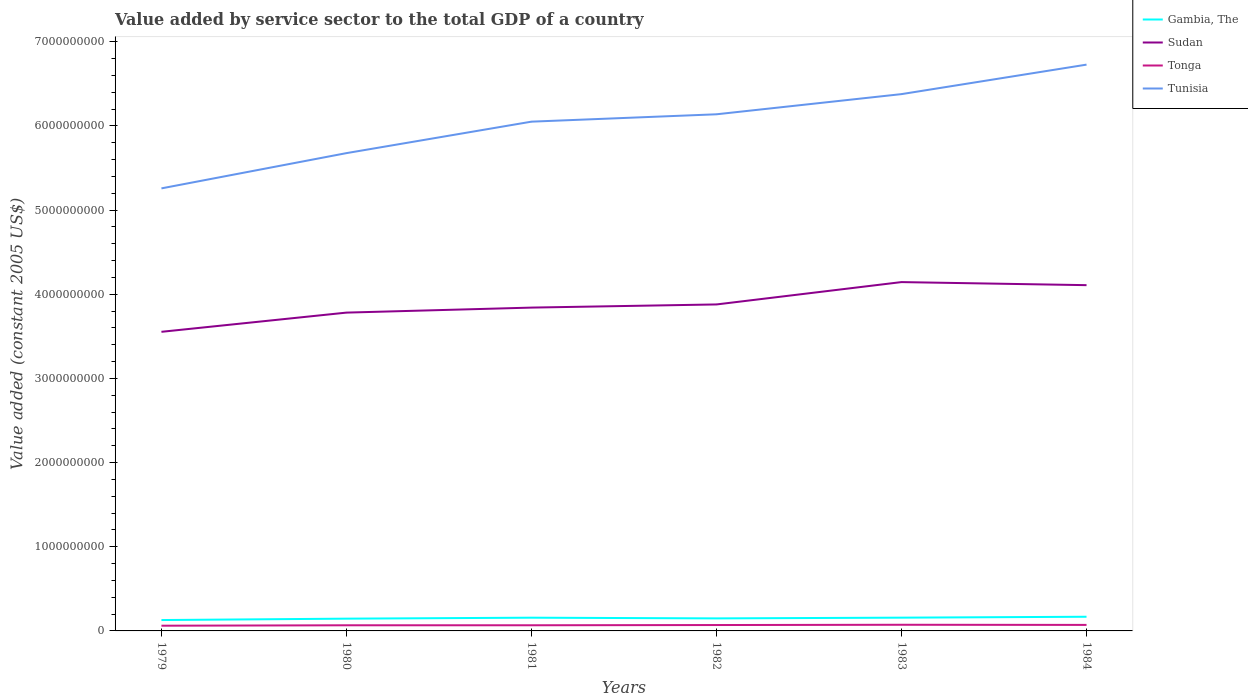Is the number of lines equal to the number of legend labels?
Ensure brevity in your answer.  Yes. Across all years, what is the maximum value added by service sector in Sudan?
Give a very brief answer. 3.55e+09. In which year was the value added by service sector in Tonga maximum?
Ensure brevity in your answer.  1979. What is the total value added by service sector in Tonga in the graph?
Your answer should be very brief. -7.98e+06. What is the difference between the highest and the second highest value added by service sector in Tonga?
Provide a succinct answer. 1.13e+07. What is the difference between the highest and the lowest value added by service sector in Tunisia?
Offer a very short reply. 4. How many lines are there?
Your answer should be compact. 4. How many years are there in the graph?
Your answer should be compact. 6. Does the graph contain any zero values?
Your answer should be compact. No. Does the graph contain grids?
Give a very brief answer. No. Where does the legend appear in the graph?
Provide a succinct answer. Top right. What is the title of the graph?
Your answer should be very brief. Value added by service sector to the total GDP of a country. Does "Micronesia" appear as one of the legend labels in the graph?
Offer a very short reply. No. What is the label or title of the X-axis?
Provide a short and direct response. Years. What is the label or title of the Y-axis?
Give a very brief answer. Value added (constant 2005 US$). What is the Value added (constant 2005 US$) in Gambia, The in 1979?
Your response must be concise. 1.29e+08. What is the Value added (constant 2005 US$) in Sudan in 1979?
Give a very brief answer. 3.55e+09. What is the Value added (constant 2005 US$) of Tonga in 1979?
Offer a terse response. 6.19e+07. What is the Value added (constant 2005 US$) in Tunisia in 1979?
Ensure brevity in your answer.  5.26e+09. What is the Value added (constant 2005 US$) of Gambia, The in 1980?
Provide a short and direct response. 1.46e+08. What is the Value added (constant 2005 US$) of Sudan in 1980?
Your response must be concise. 3.78e+09. What is the Value added (constant 2005 US$) in Tonga in 1980?
Provide a short and direct response. 6.69e+07. What is the Value added (constant 2005 US$) in Tunisia in 1980?
Provide a succinct answer. 5.68e+09. What is the Value added (constant 2005 US$) in Gambia, The in 1981?
Give a very brief answer. 1.57e+08. What is the Value added (constant 2005 US$) in Sudan in 1981?
Make the answer very short. 3.84e+09. What is the Value added (constant 2005 US$) in Tonga in 1981?
Keep it short and to the point. 6.73e+07. What is the Value added (constant 2005 US$) in Tunisia in 1981?
Your response must be concise. 6.05e+09. What is the Value added (constant 2005 US$) in Gambia, The in 1982?
Provide a succinct answer. 1.49e+08. What is the Value added (constant 2005 US$) in Sudan in 1982?
Your answer should be very brief. 3.88e+09. What is the Value added (constant 2005 US$) of Tonga in 1982?
Offer a terse response. 6.99e+07. What is the Value added (constant 2005 US$) of Tunisia in 1982?
Your answer should be compact. 6.14e+09. What is the Value added (constant 2005 US$) in Gambia, The in 1983?
Keep it short and to the point. 1.58e+08. What is the Value added (constant 2005 US$) in Sudan in 1983?
Offer a very short reply. 4.14e+09. What is the Value added (constant 2005 US$) in Tonga in 1983?
Provide a short and direct response. 7.32e+07. What is the Value added (constant 2005 US$) in Tunisia in 1983?
Make the answer very short. 6.38e+09. What is the Value added (constant 2005 US$) of Gambia, The in 1984?
Keep it short and to the point. 1.68e+08. What is the Value added (constant 2005 US$) of Sudan in 1984?
Make the answer very short. 4.11e+09. What is the Value added (constant 2005 US$) in Tonga in 1984?
Your response must be concise. 7.14e+07. What is the Value added (constant 2005 US$) of Tunisia in 1984?
Offer a very short reply. 6.73e+09. Across all years, what is the maximum Value added (constant 2005 US$) in Gambia, The?
Offer a very short reply. 1.68e+08. Across all years, what is the maximum Value added (constant 2005 US$) of Sudan?
Your answer should be very brief. 4.14e+09. Across all years, what is the maximum Value added (constant 2005 US$) in Tonga?
Ensure brevity in your answer.  7.32e+07. Across all years, what is the maximum Value added (constant 2005 US$) in Tunisia?
Your answer should be compact. 6.73e+09. Across all years, what is the minimum Value added (constant 2005 US$) of Gambia, The?
Your answer should be compact. 1.29e+08. Across all years, what is the minimum Value added (constant 2005 US$) of Sudan?
Your answer should be very brief. 3.55e+09. Across all years, what is the minimum Value added (constant 2005 US$) in Tonga?
Your response must be concise. 6.19e+07. Across all years, what is the minimum Value added (constant 2005 US$) of Tunisia?
Your response must be concise. 5.26e+09. What is the total Value added (constant 2005 US$) of Gambia, The in the graph?
Make the answer very short. 9.07e+08. What is the total Value added (constant 2005 US$) in Sudan in the graph?
Give a very brief answer. 2.33e+1. What is the total Value added (constant 2005 US$) of Tonga in the graph?
Give a very brief answer. 4.11e+08. What is the total Value added (constant 2005 US$) of Tunisia in the graph?
Your response must be concise. 3.62e+1. What is the difference between the Value added (constant 2005 US$) of Gambia, The in 1979 and that in 1980?
Offer a terse response. -1.66e+07. What is the difference between the Value added (constant 2005 US$) in Sudan in 1979 and that in 1980?
Provide a succinct answer. -2.28e+08. What is the difference between the Value added (constant 2005 US$) of Tonga in 1979 and that in 1980?
Your answer should be very brief. -4.99e+06. What is the difference between the Value added (constant 2005 US$) in Tunisia in 1979 and that in 1980?
Offer a terse response. -4.19e+08. What is the difference between the Value added (constant 2005 US$) in Gambia, The in 1979 and that in 1981?
Offer a terse response. -2.81e+07. What is the difference between the Value added (constant 2005 US$) of Sudan in 1979 and that in 1981?
Your response must be concise. -2.88e+08. What is the difference between the Value added (constant 2005 US$) in Tonga in 1979 and that in 1981?
Offer a terse response. -5.32e+06. What is the difference between the Value added (constant 2005 US$) in Tunisia in 1979 and that in 1981?
Ensure brevity in your answer.  -7.93e+08. What is the difference between the Value added (constant 2005 US$) of Gambia, The in 1979 and that in 1982?
Offer a very short reply. -1.98e+07. What is the difference between the Value added (constant 2005 US$) of Sudan in 1979 and that in 1982?
Provide a succinct answer. -3.25e+08. What is the difference between the Value added (constant 2005 US$) in Tonga in 1979 and that in 1982?
Your answer should be compact. -7.98e+06. What is the difference between the Value added (constant 2005 US$) in Tunisia in 1979 and that in 1982?
Provide a succinct answer. -8.80e+08. What is the difference between the Value added (constant 2005 US$) of Gambia, The in 1979 and that in 1983?
Provide a short and direct response. -2.84e+07. What is the difference between the Value added (constant 2005 US$) in Sudan in 1979 and that in 1983?
Make the answer very short. -5.91e+08. What is the difference between the Value added (constant 2005 US$) of Tonga in 1979 and that in 1983?
Your answer should be compact. -1.13e+07. What is the difference between the Value added (constant 2005 US$) in Tunisia in 1979 and that in 1983?
Your answer should be very brief. -1.12e+09. What is the difference between the Value added (constant 2005 US$) in Gambia, The in 1979 and that in 1984?
Make the answer very short. -3.92e+07. What is the difference between the Value added (constant 2005 US$) in Sudan in 1979 and that in 1984?
Your response must be concise. -5.54e+08. What is the difference between the Value added (constant 2005 US$) in Tonga in 1979 and that in 1984?
Provide a short and direct response. -9.49e+06. What is the difference between the Value added (constant 2005 US$) of Tunisia in 1979 and that in 1984?
Make the answer very short. -1.47e+09. What is the difference between the Value added (constant 2005 US$) of Gambia, The in 1980 and that in 1981?
Give a very brief answer. -1.15e+07. What is the difference between the Value added (constant 2005 US$) in Sudan in 1980 and that in 1981?
Provide a succinct answer. -5.95e+07. What is the difference between the Value added (constant 2005 US$) of Tonga in 1980 and that in 1981?
Offer a very short reply. -3.28e+05. What is the difference between the Value added (constant 2005 US$) of Tunisia in 1980 and that in 1981?
Offer a terse response. -3.74e+08. What is the difference between the Value added (constant 2005 US$) of Gambia, The in 1980 and that in 1982?
Offer a very short reply. -3.16e+06. What is the difference between the Value added (constant 2005 US$) in Sudan in 1980 and that in 1982?
Give a very brief answer. -9.70e+07. What is the difference between the Value added (constant 2005 US$) in Tonga in 1980 and that in 1982?
Your answer should be compact. -2.99e+06. What is the difference between the Value added (constant 2005 US$) in Tunisia in 1980 and that in 1982?
Offer a very short reply. -4.61e+08. What is the difference between the Value added (constant 2005 US$) of Gambia, The in 1980 and that in 1983?
Offer a terse response. -1.18e+07. What is the difference between the Value added (constant 2005 US$) in Sudan in 1980 and that in 1983?
Keep it short and to the point. -3.63e+08. What is the difference between the Value added (constant 2005 US$) of Tonga in 1980 and that in 1983?
Give a very brief answer. -6.26e+06. What is the difference between the Value added (constant 2005 US$) of Tunisia in 1980 and that in 1983?
Your response must be concise. -7.01e+08. What is the difference between the Value added (constant 2005 US$) of Gambia, The in 1980 and that in 1984?
Provide a succinct answer. -2.26e+07. What is the difference between the Value added (constant 2005 US$) of Sudan in 1980 and that in 1984?
Make the answer very short. -3.26e+08. What is the difference between the Value added (constant 2005 US$) in Tonga in 1980 and that in 1984?
Keep it short and to the point. -4.50e+06. What is the difference between the Value added (constant 2005 US$) of Tunisia in 1980 and that in 1984?
Your answer should be compact. -1.05e+09. What is the difference between the Value added (constant 2005 US$) of Gambia, The in 1981 and that in 1982?
Offer a very short reply. 8.32e+06. What is the difference between the Value added (constant 2005 US$) of Sudan in 1981 and that in 1982?
Your answer should be compact. -3.75e+07. What is the difference between the Value added (constant 2005 US$) of Tonga in 1981 and that in 1982?
Make the answer very short. -2.66e+06. What is the difference between the Value added (constant 2005 US$) in Tunisia in 1981 and that in 1982?
Your answer should be very brief. -8.75e+07. What is the difference between the Value added (constant 2005 US$) in Gambia, The in 1981 and that in 1983?
Offer a terse response. -3.12e+05. What is the difference between the Value added (constant 2005 US$) in Sudan in 1981 and that in 1983?
Offer a very short reply. -3.03e+08. What is the difference between the Value added (constant 2005 US$) in Tonga in 1981 and that in 1983?
Keep it short and to the point. -5.94e+06. What is the difference between the Value added (constant 2005 US$) in Tunisia in 1981 and that in 1983?
Provide a succinct answer. -3.27e+08. What is the difference between the Value added (constant 2005 US$) of Gambia, The in 1981 and that in 1984?
Keep it short and to the point. -1.11e+07. What is the difference between the Value added (constant 2005 US$) of Sudan in 1981 and that in 1984?
Give a very brief answer. -2.67e+08. What is the difference between the Value added (constant 2005 US$) in Tonga in 1981 and that in 1984?
Your answer should be compact. -4.17e+06. What is the difference between the Value added (constant 2005 US$) of Tunisia in 1981 and that in 1984?
Provide a succinct answer. -6.77e+08. What is the difference between the Value added (constant 2005 US$) in Gambia, The in 1982 and that in 1983?
Your response must be concise. -8.63e+06. What is the difference between the Value added (constant 2005 US$) of Sudan in 1982 and that in 1983?
Offer a very short reply. -2.66e+08. What is the difference between the Value added (constant 2005 US$) in Tonga in 1982 and that in 1983?
Ensure brevity in your answer.  -3.27e+06. What is the difference between the Value added (constant 2005 US$) of Tunisia in 1982 and that in 1983?
Keep it short and to the point. -2.40e+08. What is the difference between the Value added (constant 2005 US$) of Gambia, The in 1982 and that in 1984?
Your answer should be very brief. -1.94e+07. What is the difference between the Value added (constant 2005 US$) in Sudan in 1982 and that in 1984?
Keep it short and to the point. -2.29e+08. What is the difference between the Value added (constant 2005 US$) of Tonga in 1982 and that in 1984?
Your answer should be very brief. -1.51e+06. What is the difference between the Value added (constant 2005 US$) in Tunisia in 1982 and that in 1984?
Ensure brevity in your answer.  -5.90e+08. What is the difference between the Value added (constant 2005 US$) of Gambia, The in 1983 and that in 1984?
Your response must be concise. -1.08e+07. What is the difference between the Value added (constant 2005 US$) of Sudan in 1983 and that in 1984?
Your response must be concise. 3.65e+07. What is the difference between the Value added (constant 2005 US$) in Tonga in 1983 and that in 1984?
Ensure brevity in your answer.  1.77e+06. What is the difference between the Value added (constant 2005 US$) in Tunisia in 1983 and that in 1984?
Provide a succinct answer. -3.50e+08. What is the difference between the Value added (constant 2005 US$) of Gambia, The in 1979 and the Value added (constant 2005 US$) of Sudan in 1980?
Provide a succinct answer. -3.65e+09. What is the difference between the Value added (constant 2005 US$) in Gambia, The in 1979 and the Value added (constant 2005 US$) in Tonga in 1980?
Your answer should be compact. 6.22e+07. What is the difference between the Value added (constant 2005 US$) of Gambia, The in 1979 and the Value added (constant 2005 US$) of Tunisia in 1980?
Give a very brief answer. -5.55e+09. What is the difference between the Value added (constant 2005 US$) in Sudan in 1979 and the Value added (constant 2005 US$) in Tonga in 1980?
Make the answer very short. 3.49e+09. What is the difference between the Value added (constant 2005 US$) in Sudan in 1979 and the Value added (constant 2005 US$) in Tunisia in 1980?
Offer a very short reply. -2.12e+09. What is the difference between the Value added (constant 2005 US$) in Tonga in 1979 and the Value added (constant 2005 US$) in Tunisia in 1980?
Your answer should be compact. -5.61e+09. What is the difference between the Value added (constant 2005 US$) in Gambia, The in 1979 and the Value added (constant 2005 US$) in Sudan in 1981?
Your response must be concise. -3.71e+09. What is the difference between the Value added (constant 2005 US$) in Gambia, The in 1979 and the Value added (constant 2005 US$) in Tonga in 1981?
Ensure brevity in your answer.  6.18e+07. What is the difference between the Value added (constant 2005 US$) of Gambia, The in 1979 and the Value added (constant 2005 US$) of Tunisia in 1981?
Offer a terse response. -5.92e+09. What is the difference between the Value added (constant 2005 US$) in Sudan in 1979 and the Value added (constant 2005 US$) in Tonga in 1981?
Your response must be concise. 3.49e+09. What is the difference between the Value added (constant 2005 US$) in Sudan in 1979 and the Value added (constant 2005 US$) in Tunisia in 1981?
Give a very brief answer. -2.50e+09. What is the difference between the Value added (constant 2005 US$) in Tonga in 1979 and the Value added (constant 2005 US$) in Tunisia in 1981?
Ensure brevity in your answer.  -5.99e+09. What is the difference between the Value added (constant 2005 US$) in Gambia, The in 1979 and the Value added (constant 2005 US$) in Sudan in 1982?
Your response must be concise. -3.75e+09. What is the difference between the Value added (constant 2005 US$) in Gambia, The in 1979 and the Value added (constant 2005 US$) in Tonga in 1982?
Make the answer very short. 5.92e+07. What is the difference between the Value added (constant 2005 US$) of Gambia, The in 1979 and the Value added (constant 2005 US$) of Tunisia in 1982?
Ensure brevity in your answer.  -6.01e+09. What is the difference between the Value added (constant 2005 US$) of Sudan in 1979 and the Value added (constant 2005 US$) of Tonga in 1982?
Your answer should be compact. 3.48e+09. What is the difference between the Value added (constant 2005 US$) in Sudan in 1979 and the Value added (constant 2005 US$) in Tunisia in 1982?
Make the answer very short. -2.58e+09. What is the difference between the Value added (constant 2005 US$) of Tonga in 1979 and the Value added (constant 2005 US$) of Tunisia in 1982?
Give a very brief answer. -6.08e+09. What is the difference between the Value added (constant 2005 US$) in Gambia, The in 1979 and the Value added (constant 2005 US$) in Sudan in 1983?
Give a very brief answer. -4.01e+09. What is the difference between the Value added (constant 2005 US$) of Gambia, The in 1979 and the Value added (constant 2005 US$) of Tonga in 1983?
Provide a succinct answer. 5.59e+07. What is the difference between the Value added (constant 2005 US$) in Gambia, The in 1979 and the Value added (constant 2005 US$) in Tunisia in 1983?
Make the answer very short. -6.25e+09. What is the difference between the Value added (constant 2005 US$) of Sudan in 1979 and the Value added (constant 2005 US$) of Tonga in 1983?
Your response must be concise. 3.48e+09. What is the difference between the Value added (constant 2005 US$) in Sudan in 1979 and the Value added (constant 2005 US$) in Tunisia in 1983?
Provide a short and direct response. -2.82e+09. What is the difference between the Value added (constant 2005 US$) of Tonga in 1979 and the Value added (constant 2005 US$) of Tunisia in 1983?
Your answer should be very brief. -6.32e+09. What is the difference between the Value added (constant 2005 US$) in Gambia, The in 1979 and the Value added (constant 2005 US$) in Sudan in 1984?
Your answer should be compact. -3.98e+09. What is the difference between the Value added (constant 2005 US$) of Gambia, The in 1979 and the Value added (constant 2005 US$) of Tonga in 1984?
Ensure brevity in your answer.  5.77e+07. What is the difference between the Value added (constant 2005 US$) in Gambia, The in 1979 and the Value added (constant 2005 US$) in Tunisia in 1984?
Give a very brief answer. -6.60e+09. What is the difference between the Value added (constant 2005 US$) in Sudan in 1979 and the Value added (constant 2005 US$) in Tonga in 1984?
Provide a short and direct response. 3.48e+09. What is the difference between the Value added (constant 2005 US$) in Sudan in 1979 and the Value added (constant 2005 US$) in Tunisia in 1984?
Provide a succinct answer. -3.17e+09. What is the difference between the Value added (constant 2005 US$) of Tonga in 1979 and the Value added (constant 2005 US$) of Tunisia in 1984?
Provide a succinct answer. -6.67e+09. What is the difference between the Value added (constant 2005 US$) in Gambia, The in 1980 and the Value added (constant 2005 US$) in Sudan in 1981?
Provide a succinct answer. -3.70e+09. What is the difference between the Value added (constant 2005 US$) in Gambia, The in 1980 and the Value added (constant 2005 US$) in Tonga in 1981?
Provide a succinct answer. 7.85e+07. What is the difference between the Value added (constant 2005 US$) in Gambia, The in 1980 and the Value added (constant 2005 US$) in Tunisia in 1981?
Your response must be concise. -5.90e+09. What is the difference between the Value added (constant 2005 US$) in Sudan in 1980 and the Value added (constant 2005 US$) in Tonga in 1981?
Offer a terse response. 3.71e+09. What is the difference between the Value added (constant 2005 US$) of Sudan in 1980 and the Value added (constant 2005 US$) of Tunisia in 1981?
Offer a very short reply. -2.27e+09. What is the difference between the Value added (constant 2005 US$) of Tonga in 1980 and the Value added (constant 2005 US$) of Tunisia in 1981?
Provide a succinct answer. -5.98e+09. What is the difference between the Value added (constant 2005 US$) of Gambia, The in 1980 and the Value added (constant 2005 US$) of Sudan in 1982?
Offer a terse response. -3.73e+09. What is the difference between the Value added (constant 2005 US$) of Gambia, The in 1980 and the Value added (constant 2005 US$) of Tonga in 1982?
Ensure brevity in your answer.  7.58e+07. What is the difference between the Value added (constant 2005 US$) in Gambia, The in 1980 and the Value added (constant 2005 US$) in Tunisia in 1982?
Keep it short and to the point. -5.99e+09. What is the difference between the Value added (constant 2005 US$) in Sudan in 1980 and the Value added (constant 2005 US$) in Tonga in 1982?
Offer a terse response. 3.71e+09. What is the difference between the Value added (constant 2005 US$) in Sudan in 1980 and the Value added (constant 2005 US$) in Tunisia in 1982?
Your response must be concise. -2.36e+09. What is the difference between the Value added (constant 2005 US$) in Tonga in 1980 and the Value added (constant 2005 US$) in Tunisia in 1982?
Offer a very short reply. -6.07e+09. What is the difference between the Value added (constant 2005 US$) in Gambia, The in 1980 and the Value added (constant 2005 US$) in Sudan in 1983?
Provide a short and direct response. -4.00e+09. What is the difference between the Value added (constant 2005 US$) in Gambia, The in 1980 and the Value added (constant 2005 US$) in Tonga in 1983?
Offer a very short reply. 7.25e+07. What is the difference between the Value added (constant 2005 US$) in Gambia, The in 1980 and the Value added (constant 2005 US$) in Tunisia in 1983?
Keep it short and to the point. -6.23e+09. What is the difference between the Value added (constant 2005 US$) in Sudan in 1980 and the Value added (constant 2005 US$) in Tonga in 1983?
Provide a succinct answer. 3.71e+09. What is the difference between the Value added (constant 2005 US$) of Sudan in 1980 and the Value added (constant 2005 US$) of Tunisia in 1983?
Make the answer very short. -2.60e+09. What is the difference between the Value added (constant 2005 US$) in Tonga in 1980 and the Value added (constant 2005 US$) in Tunisia in 1983?
Offer a terse response. -6.31e+09. What is the difference between the Value added (constant 2005 US$) in Gambia, The in 1980 and the Value added (constant 2005 US$) in Sudan in 1984?
Keep it short and to the point. -3.96e+09. What is the difference between the Value added (constant 2005 US$) in Gambia, The in 1980 and the Value added (constant 2005 US$) in Tonga in 1984?
Your response must be concise. 7.43e+07. What is the difference between the Value added (constant 2005 US$) of Gambia, The in 1980 and the Value added (constant 2005 US$) of Tunisia in 1984?
Offer a very short reply. -6.58e+09. What is the difference between the Value added (constant 2005 US$) in Sudan in 1980 and the Value added (constant 2005 US$) in Tonga in 1984?
Provide a succinct answer. 3.71e+09. What is the difference between the Value added (constant 2005 US$) of Sudan in 1980 and the Value added (constant 2005 US$) of Tunisia in 1984?
Provide a short and direct response. -2.95e+09. What is the difference between the Value added (constant 2005 US$) of Tonga in 1980 and the Value added (constant 2005 US$) of Tunisia in 1984?
Provide a succinct answer. -6.66e+09. What is the difference between the Value added (constant 2005 US$) of Gambia, The in 1981 and the Value added (constant 2005 US$) of Sudan in 1982?
Your answer should be very brief. -3.72e+09. What is the difference between the Value added (constant 2005 US$) of Gambia, The in 1981 and the Value added (constant 2005 US$) of Tonga in 1982?
Provide a succinct answer. 8.73e+07. What is the difference between the Value added (constant 2005 US$) in Gambia, The in 1981 and the Value added (constant 2005 US$) in Tunisia in 1982?
Ensure brevity in your answer.  -5.98e+09. What is the difference between the Value added (constant 2005 US$) in Sudan in 1981 and the Value added (constant 2005 US$) in Tonga in 1982?
Your answer should be very brief. 3.77e+09. What is the difference between the Value added (constant 2005 US$) in Sudan in 1981 and the Value added (constant 2005 US$) in Tunisia in 1982?
Keep it short and to the point. -2.30e+09. What is the difference between the Value added (constant 2005 US$) in Tonga in 1981 and the Value added (constant 2005 US$) in Tunisia in 1982?
Give a very brief answer. -6.07e+09. What is the difference between the Value added (constant 2005 US$) in Gambia, The in 1981 and the Value added (constant 2005 US$) in Sudan in 1983?
Offer a terse response. -3.99e+09. What is the difference between the Value added (constant 2005 US$) in Gambia, The in 1981 and the Value added (constant 2005 US$) in Tonga in 1983?
Provide a succinct answer. 8.40e+07. What is the difference between the Value added (constant 2005 US$) of Gambia, The in 1981 and the Value added (constant 2005 US$) of Tunisia in 1983?
Make the answer very short. -6.22e+09. What is the difference between the Value added (constant 2005 US$) in Sudan in 1981 and the Value added (constant 2005 US$) in Tonga in 1983?
Offer a terse response. 3.77e+09. What is the difference between the Value added (constant 2005 US$) of Sudan in 1981 and the Value added (constant 2005 US$) of Tunisia in 1983?
Provide a short and direct response. -2.54e+09. What is the difference between the Value added (constant 2005 US$) of Tonga in 1981 and the Value added (constant 2005 US$) of Tunisia in 1983?
Your answer should be very brief. -6.31e+09. What is the difference between the Value added (constant 2005 US$) of Gambia, The in 1981 and the Value added (constant 2005 US$) of Sudan in 1984?
Ensure brevity in your answer.  -3.95e+09. What is the difference between the Value added (constant 2005 US$) of Gambia, The in 1981 and the Value added (constant 2005 US$) of Tonga in 1984?
Ensure brevity in your answer.  8.58e+07. What is the difference between the Value added (constant 2005 US$) in Gambia, The in 1981 and the Value added (constant 2005 US$) in Tunisia in 1984?
Offer a very short reply. -6.57e+09. What is the difference between the Value added (constant 2005 US$) in Sudan in 1981 and the Value added (constant 2005 US$) in Tonga in 1984?
Your answer should be compact. 3.77e+09. What is the difference between the Value added (constant 2005 US$) in Sudan in 1981 and the Value added (constant 2005 US$) in Tunisia in 1984?
Keep it short and to the point. -2.89e+09. What is the difference between the Value added (constant 2005 US$) of Tonga in 1981 and the Value added (constant 2005 US$) of Tunisia in 1984?
Your response must be concise. -6.66e+09. What is the difference between the Value added (constant 2005 US$) of Gambia, The in 1982 and the Value added (constant 2005 US$) of Sudan in 1983?
Keep it short and to the point. -4.00e+09. What is the difference between the Value added (constant 2005 US$) in Gambia, The in 1982 and the Value added (constant 2005 US$) in Tonga in 1983?
Ensure brevity in your answer.  7.57e+07. What is the difference between the Value added (constant 2005 US$) of Gambia, The in 1982 and the Value added (constant 2005 US$) of Tunisia in 1983?
Offer a terse response. -6.23e+09. What is the difference between the Value added (constant 2005 US$) of Sudan in 1982 and the Value added (constant 2005 US$) of Tonga in 1983?
Offer a terse response. 3.81e+09. What is the difference between the Value added (constant 2005 US$) in Sudan in 1982 and the Value added (constant 2005 US$) in Tunisia in 1983?
Provide a succinct answer. -2.50e+09. What is the difference between the Value added (constant 2005 US$) of Tonga in 1982 and the Value added (constant 2005 US$) of Tunisia in 1983?
Ensure brevity in your answer.  -6.31e+09. What is the difference between the Value added (constant 2005 US$) in Gambia, The in 1982 and the Value added (constant 2005 US$) in Sudan in 1984?
Keep it short and to the point. -3.96e+09. What is the difference between the Value added (constant 2005 US$) of Gambia, The in 1982 and the Value added (constant 2005 US$) of Tonga in 1984?
Make the answer very short. 7.74e+07. What is the difference between the Value added (constant 2005 US$) in Gambia, The in 1982 and the Value added (constant 2005 US$) in Tunisia in 1984?
Your answer should be compact. -6.58e+09. What is the difference between the Value added (constant 2005 US$) of Sudan in 1982 and the Value added (constant 2005 US$) of Tonga in 1984?
Your answer should be very brief. 3.81e+09. What is the difference between the Value added (constant 2005 US$) in Sudan in 1982 and the Value added (constant 2005 US$) in Tunisia in 1984?
Provide a succinct answer. -2.85e+09. What is the difference between the Value added (constant 2005 US$) of Tonga in 1982 and the Value added (constant 2005 US$) of Tunisia in 1984?
Give a very brief answer. -6.66e+09. What is the difference between the Value added (constant 2005 US$) of Gambia, The in 1983 and the Value added (constant 2005 US$) of Sudan in 1984?
Offer a terse response. -3.95e+09. What is the difference between the Value added (constant 2005 US$) of Gambia, The in 1983 and the Value added (constant 2005 US$) of Tonga in 1984?
Ensure brevity in your answer.  8.61e+07. What is the difference between the Value added (constant 2005 US$) of Gambia, The in 1983 and the Value added (constant 2005 US$) of Tunisia in 1984?
Offer a very short reply. -6.57e+09. What is the difference between the Value added (constant 2005 US$) in Sudan in 1983 and the Value added (constant 2005 US$) in Tonga in 1984?
Provide a succinct answer. 4.07e+09. What is the difference between the Value added (constant 2005 US$) in Sudan in 1983 and the Value added (constant 2005 US$) in Tunisia in 1984?
Offer a terse response. -2.58e+09. What is the difference between the Value added (constant 2005 US$) in Tonga in 1983 and the Value added (constant 2005 US$) in Tunisia in 1984?
Offer a very short reply. -6.65e+09. What is the average Value added (constant 2005 US$) of Gambia, The per year?
Make the answer very short. 1.51e+08. What is the average Value added (constant 2005 US$) in Sudan per year?
Offer a terse response. 3.88e+09. What is the average Value added (constant 2005 US$) in Tonga per year?
Ensure brevity in your answer.  6.85e+07. What is the average Value added (constant 2005 US$) of Tunisia per year?
Give a very brief answer. 6.04e+09. In the year 1979, what is the difference between the Value added (constant 2005 US$) of Gambia, The and Value added (constant 2005 US$) of Sudan?
Provide a short and direct response. -3.42e+09. In the year 1979, what is the difference between the Value added (constant 2005 US$) of Gambia, The and Value added (constant 2005 US$) of Tonga?
Offer a terse response. 6.72e+07. In the year 1979, what is the difference between the Value added (constant 2005 US$) of Gambia, The and Value added (constant 2005 US$) of Tunisia?
Make the answer very short. -5.13e+09. In the year 1979, what is the difference between the Value added (constant 2005 US$) in Sudan and Value added (constant 2005 US$) in Tonga?
Offer a terse response. 3.49e+09. In the year 1979, what is the difference between the Value added (constant 2005 US$) in Sudan and Value added (constant 2005 US$) in Tunisia?
Your response must be concise. -1.70e+09. In the year 1979, what is the difference between the Value added (constant 2005 US$) in Tonga and Value added (constant 2005 US$) in Tunisia?
Your answer should be very brief. -5.20e+09. In the year 1980, what is the difference between the Value added (constant 2005 US$) in Gambia, The and Value added (constant 2005 US$) in Sudan?
Offer a very short reply. -3.64e+09. In the year 1980, what is the difference between the Value added (constant 2005 US$) of Gambia, The and Value added (constant 2005 US$) of Tonga?
Keep it short and to the point. 7.88e+07. In the year 1980, what is the difference between the Value added (constant 2005 US$) of Gambia, The and Value added (constant 2005 US$) of Tunisia?
Your response must be concise. -5.53e+09. In the year 1980, what is the difference between the Value added (constant 2005 US$) in Sudan and Value added (constant 2005 US$) in Tonga?
Your response must be concise. 3.71e+09. In the year 1980, what is the difference between the Value added (constant 2005 US$) in Sudan and Value added (constant 2005 US$) in Tunisia?
Make the answer very short. -1.89e+09. In the year 1980, what is the difference between the Value added (constant 2005 US$) of Tonga and Value added (constant 2005 US$) of Tunisia?
Make the answer very short. -5.61e+09. In the year 1981, what is the difference between the Value added (constant 2005 US$) in Gambia, The and Value added (constant 2005 US$) in Sudan?
Your response must be concise. -3.68e+09. In the year 1981, what is the difference between the Value added (constant 2005 US$) of Gambia, The and Value added (constant 2005 US$) of Tonga?
Offer a terse response. 8.99e+07. In the year 1981, what is the difference between the Value added (constant 2005 US$) of Gambia, The and Value added (constant 2005 US$) of Tunisia?
Your answer should be very brief. -5.89e+09. In the year 1981, what is the difference between the Value added (constant 2005 US$) in Sudan and Value added (constant 2005 US$) in Tonga?
Keep it short and to the point. 3.77e+09. In the year 1981, what is the difference between the Value added (constant 2005 US$) of Sudan and Value added (constant 2005 US$) of Tunisia?
Give a very brief answer. -2.21e+09. In the year 1981, what is the difference between the Value added (constant 2005 US$) in Tonga and Value added (constant 2005 US$) in Tunisia?
Your answer should be very brief. -5.98e+09. In the year 1982, what is the difference between the Value added (constant 2005 US$) in Gambia, The and Value added (constant 2005 US$) in Sudan?
Your answer should be very brief. -3.73e+09. In the year 1982, what is the difference between the Value added (constant 2005 US$) of Gambia, The and Value added (constant 2005 US$) of Tonga?
Offer a very short reply. 7.90e+07. In the year 1982, what is the difference between the Value added (constant 2005 US$) of Gambia, The and Value added (constant 2005 US$) of Tunisia?
Your answer should be compact. -5.99e+09. In the year 1982, what is the difference between the Value added (constant 2005 US$) in Sudan and Value added (constant 2005 US$) in Tonga?
Provide a short and direct response. 3.81e+09. In the year 1982, what is the difference between the Value added (constant 2005 US$) in Sudan and Value added (constant 2005 US$) in Tunisia?
Make the answer very short. -2.26e+09. In the year 1982, what is the difference between the Value added (constant 2005 US$) in Tonga and Value added (constant 2005 US$) in Tunisia?
Offer a terse response. -6.07e+09. In the year 1983, what is the difference between the Value added (constant 2005 US$) of Gambia, The and Value added (constant 2005 US$) of Sudan?
Ensure brevity in your answer.  -3.99e+09. In the year 1983, what is the difference between the Value added (constant 2005 US$) in Gambia, The and Value added (constant 2005 US$) in Tonga?
Provide a succinct answer. 8.43e+07. In the year 1983, what is the difference between the Value added (constant 2005 US$) in Gambia, The and Value added (constant 2005 US$) in Tunisia?
Keep it short and to the point. -6.22e+09. In the year 1983, what is the difference between the Value added (constant 2005 US$) in Sudan and Value added (constant 2005 US$) in Tonga?
Your answer should be very brief. 4.07e+09. In the year 1983, what is the difference between the Value added (constant 2005 US$) of Sudan and Value added (constant 2005 US$) of Tunisia?
Keep it short and to the point. -2.23e+09. In the year 1983, what is the difference between the Value added (constant 2005 US$) of Tonga and Value added (constant 2005 US$) of Tunisia?
Provide a short and direct response. -6.30e+09. In the year 1984, what is the difference between the Value added (constant 2005 US$) of Gambia, The and Value added (constant 2005 US$) of Sudan?
Keep it short and to the point. -3.94e+09. In the year 1984, what is the difference between the Value added (constant 2005 US$) in Gambia, The and Value added (constant 2005 US$) in Tonga?
Ensure brevity in your answer.  9.69e+07. In the year 1984, what is the difference between the Value added (constant 2005 US$) of Gambia, The and Value added (constant 2005 US$) of Tunisia?
Your answer should be very brief. -6.56e+09. In the year 1984, what is the difference between the Value added (constant 2005 US$) in Sudan and Value added (constant 2005 US$) in Tonga?
Offer a very short reply. 4.04e+09. In the year 1984, what is the difference between the Value added (constant 2005 US$) in Sudan and Value added (constant 2005 US$) in Tunisia?
Offer a terse response. -2.62e+09. In the year 1984, what is the difference between the Value added (constant 2005 US$) in Tonga and Value added (constant 2005 US$) in Tunisia?
Offer a very short reply. -6.66e+09. What is the ratio of the Value added (constant 2005 US$) in Gambia, The in 1979 to that in 1980?
Make the answer very short. 0.89. What is the ratio of the Value added (constant 2005 US$) of Sudan in 1979 to that in 1980?
Offer a terse response. 0.94. What is the ratio of the Value added (constant 2005 US$) in Tonga in 1979 to that in 1980?
Ensure brevity in your answer.  0.93. What is the ratio of the Value added (constant 2005 US$) in Tunisia in 1979 to that in 1980?
Your answer should be very brief. 0.93. What is the ratio of the Value added (constant 2005 US$) of Gambia, The in 1979 to that in 1981?
Ensure brevity in your answer.  0.82. What is the ratio of the Value added (constant 2005 US$) of Sudan in 1979 to that in 1981?
Offer a very short reply. 0.93. What is the ratio of the Value added (constant 2005 US$) of Tonga in 1979 to that in 1981?
Provide a short and direct response. 0.92. What is the ratio of the Value added (constant 2005 US$) of Tunisia in 1979 to that in 1981?
Give a very brief answer. 0.87. What is the ratio of the Value added (constant 2005 US$) of Gambia, The in 1979 to that in 1982?
Your answer should be compact. 0.87. What is the ratio of the Value added (constant 2005 US$) of Sudan in 1979 to that in 1982?
Provide a succinct answer. 0.92. What is the ratio of the Value added (constant 2005 US$) in Tonga in 1979 to that in 1982?
Ensure brevity in your answer.  0.89. What is the ratio of the Value added (constant 2005 US$) of Tunisia in 1979 to that in 1982?
Your answer should be compact. 0.86. What is the ratio of the Value added (constant 2005 US$) of Gambia, The in 1979 to that in 1983?
Your answer should be very brief. 0.82. What is the ratio of the Value added (constant 2005 US$) of Sudan in 1979 to that in 1983?
Offer a very short reply. 0.86. What is the ratio of the Value added (constant 2005 US$) in Tonga in 1979 to that in 1983?
Keep it short and to the point. 0.85. What is the ratio of the Value added (constant 2005 US$) in Tunisia in 1979 to that in 1983?
Keep it short and to the point. 0.82. What is the ratio of the Value added (constant 2005 US$) in Gambia, The in 1979 to that in 1984?
Your answer should be compact. 0.77. What is the ratio of the Value added (constant 2005 US$) in Sudan in 1979 to that in 1984?
Your answer should be compact. 0.87. What is the ratio of the Value added (constant 2005 US$) of Tonga in 1979 to that in 1984?
Make the answer very short. 0.87. What is the ratio of the Value added (constant 2005 US$) of Tunisia in 1979 to that in 1984?
Offer a very short reply. 0.78. What is the ratio of the Value added (constant 2005 US$) in Gambia, The in 1980 to that in 1981?
Your answer should be very brief. 0.93. What is the ratio of the Value added (constant 2005 US$) of Sudan in 1980 to that in 1981?
Offer a very short reply. 0.98. What is the ratio of the Value added (constant 2005 US$) of Tunisia in 1980 to that in 1981?
Give a very brief answer. 0.94. What is the ratio of the Value added (constant 2005 US$) in Gambia, The in 1980 to that in 1982?
Offer a very short reply. 0.98. What is the ratio of the Value added (constant 2005 US$) of Sudan in 1980 to that in 1982?
Provide a succinct answer. 0.97. What is the ratio of the Value added (constant 2005 US$) in Tonga in 1980 to that in 1982?
Ensure brevity in your answer.  0.96. What is the ratio of the Value added (constant 2005 US$) of Tunisia in 1980 to that in 1982?
Keep it short and to the point. 0.92. What is the ratio of the Value added (constant 2005 US$) of Gambia, The in 1980 to that in 1983?
Provide a short and direct response. 0.93. What is the ratio of the Value added (constant 2005 US$) of Sudan in 1980 to that in 1983?
Your response must be concise. 0.91. What is the ratio of the Value added (constant 2005 US$) in Tonga in 1980 to that in 1983?
Offer a very short reply. 0.91. What is the ratio of the Value added (constant 2005 US$) of Tunisia in 1980 to that in 1983?
Make the answer very short. 0.89. What is the ratio of the Value added (constant 2005 US$) in Gambia, The in 1980 to that in 1984?
Your answer should be very brief. 0.87. What is the ratio of the Value added (constant 2005 US$) in Sudan in 1980 to that in 1984?
Offer a very short reply. 0.92. What is the ratio of the Value added (constant 2005 US$) of Tonga in 1980 to that in 1984?
Offer a terse response. 0.94. What is the ratio of the Value added (constant 2005 US$) in Tunisia in 1980 to that in 1984?
Provide a short and direct response. 0.84. What is the ratio of the Value added (constant 2005 US$) in Gambia, The in 1981 to that in 1982?
Your answer should be compact. 1.06. What is the ratio of the Value added (constant 2005 US$) in Sudan in 1981 to that in 1982?
Make the answer very short. 0.99. What is the ratio of the Value added (constant 2005 US$) of Tonga in 1981 to that in 1982?
Provide a succinct answer. 0.96. What is the ratio of the Value added (constant 2005 US$) of Tunisia in 1981 to that in 1982?
Provide a succinct answer. 0.99. What is the ratio of the Value added (constant 2005 US$) of Sudan in 1981 to that in 1983?
Offer a very short reply. 0.93. What is the ratio of the Value added (constant 2005 US$) in Tonga in 1981 to that in 1983?
Your answer should be compact. 0.92. What is the ratio of the Value added (constant 2005 US$) in Tunisia in 1981 to that in 1983?
Offer a very short reply. 0.95. What is the ratio of the Value added (constant 2005 US$) of Gambia, The in 1981 to that in 1984?
Make the answer very short. 0.93. What is the ratio of the Value added (constant 2005 US$) in Sudan in 1981 to that in 1984?
Your answer should be very brief. 0.94. What is the ratio of the Value added (constant 2005 US$) in Tonga in 1981 to that in 1984?
Offer a very short reply. 0.94. What is the ratio of the Value added (constant 2005 US$) of Tunisia in 1981 to that in 1984?
Provide a short and direct response. 0.9. What is the ratio of the Value added (constant 2005 US$) in Gambia, The in 1982 to that in 1983?
Make the answer very short. 0.95. What is the ratio of the Value added (constant 2005 US$) in Sudan in 1982 to that in 1983?
Ensure brevity in your answer.  0.94. What is the ratio of the Value added (constant 2005 US$) in Tonga in 1982 to that in 1983?
Keep it short and to the point. 0.96. What is the ratio of the Value added (constant 2005 US$) of Tunisia in 1982 to that in 1983?
Give a very brief answer. 0.96. What is the ratio of the Value added (constant 2005 US$) of Gambia, The in 1982 to that in 1984?
Keep it short and to the point. 0.88. What is the ratio of the Value added (constant 2005 US$) of Sudan in 1982 to that in 1984?
Provide a succinct answer. 0.94. What is the ratio of the Value added (constant 2005 US$) in Tonga in 1982 to that in 1984?
Give a very brief answer. 0.98. What is the ratio of the Value added (constant 2005 US$) of Tunisia in 1982 to that in 1984?
Provide a short and direct response. 0.91. What is the ratio of the Value added (constant 2005 US$) of Gambia, The in 1983 to that in 1984?
Offer a terse response. 0.94. What is the ratio of the Value added (constant 2005 US$) of Sudan in 1983 to that in 1984?
Make the answer very short. 1.01. What is the ratio of the Value added (constant 2005 US$) of Tonga in 1983 to that in 1984?
Offer a terse response. 1.02. What is the ratio of the Value added (constant 2005 US$) in Tunisia in 1983 to that in 1984?
Give a very brief answer. 0.95. What is the difference between the highest and the second highest Value added (constant 2005 US$) of Gambia, The?
Your answer should be compact. 1.08e+07. What is the difference between the highest and the second highest Value added (constant 2005 US$) of Sudan?
Offer a terse response. 3.65e+07. What is the difference between the highest and the second highest Value added (constant 2005 US$) of Tonga?
Provide a short and direct response. 1.77e+06. What is the difference between the highest and the second highest Value added (constant 2005 US$) of Tunisia?
Provide a short and direct response. 3.50e+08. What is the difference between the highest and the lowest Value added (constant 2005 US$) in Gambia, The?
Your answer should be compact. 3.92e+07. What is the difference between the highest and the lowest Value added (constant 2005 US$) of Sudan?
Offer a terse response. 5.91e+08. What is the difference between the highest and the lowest Value added (constant 2005 US$) of Tonga?
Offer a terse response. 1.13e+07. What is the difference between the highest and the lowest Value added (constant 2005 US$) of Tunisia?
Give a very brief answer. 1.47e+09. 